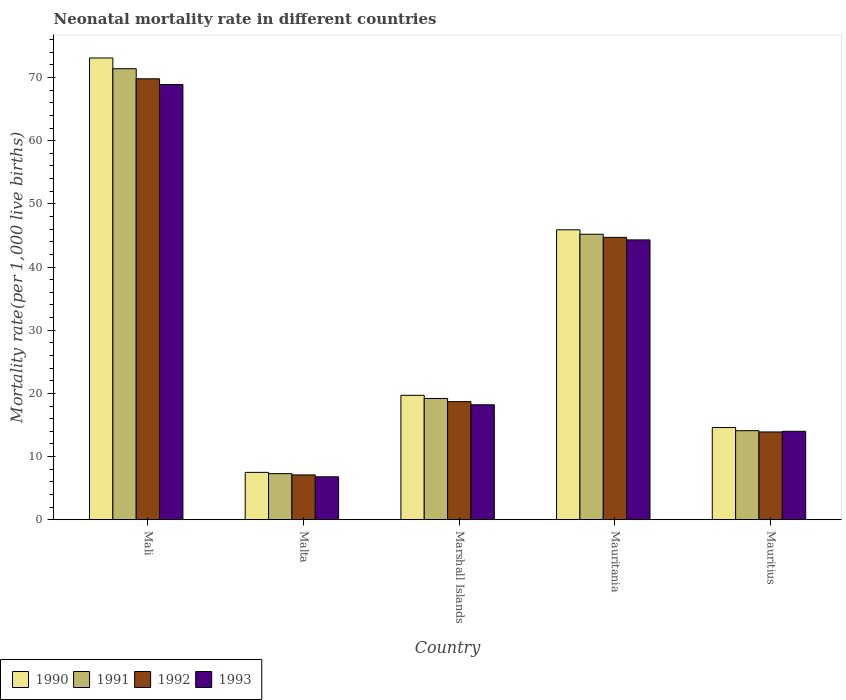How many different coloured bars are there?
Provide a short and direct response. 4. Are the number of bars on each tick of the X-axis equal?
Your answer should be compact. Yes. How many bars are there on the 2nd tick from the left?
Your answer should be very brief. 4. What is the label of the 2nd group of bars from the left?
Give a very brief answer. Malta. What is the neonatal mortality rate in 1992 in Mauritius?
Keep it short and to the point. 13.9. Across all countries, what is the maximum neonatal mortality rate in 1990?
Your answer should be compact. 73.1. Across all countries, what is the minimum neonatal mortality rate in 1991?
Keep it short and to the point. 7.3. In which country was the neonatal mortality rate in 1991 maximum?
Your answer should be very brief. Mali. In which country was the neonatal mortality rate in 1991 minimum?
Provide a short and direct response. Malta. What is the total neonatal mortality rate in 1993 in the graph?
Offer a terse response. 152.2. What is the difference between the neonatal mortality rate in 1991 in Malta and that in Mauritania?
Offer a very short reply. -37.9. What is the difference between the neonatal mortality rate in 1992 in Mauritius and the neonatal mortality rate in 1990 in Marshall Islands?
Your answer should be very brief. -5.8. What is the average neonatal mortality rate in 1992 per country?
Your answer should be very brief. 30.84. What is the difference between the neonatal mortality rate of/in 1992 and neonatal mortality rate of/in 1990 in Mali?
Offer a terse response. -3.3. In how many countries, is the neonatal mortality rate in 1990 greater than 40?
Your response must be concise. 2. What is the ratio of the neonatal mortality rate in 1990 in Marshall Islands to that in Mauritania?
Provide a short and direct response. 0.43. Is the difference between the neonatal mortality rate in 1992 in Mali and Mauritania greater than the difference between the neonatal mortality rate in 1990 in Mali and Mauritania?
Offer a very short reply. No. What is the difference between the highest and the second highest neonatal mortality rate in 1993?
Your answer should be compact. -50.7. What is the difference between the highest and the lowest neonatal mortality rate in 1990?
Make the answer very short. 65.6. In how many countries, is the neonatal mortality rate in 1993 greater than the average neonatal mortality rate in 1993 taken over all countries?
Your answer should be compact. 2. What does the 1st bar from the right in Mali represents?
Make the answer very short. 1993. Is it the case that in every country, the sum of the neonatal mortality rate in 1992 and neonatal mortality rate in 1990 is greater than the neonatal mortality rate in 1991?
Offer a terse response. Yes. How many bars are there?
Provide a succinct answer. 20. Are all the bars in the graph horizontal?
Provide a short and direct response. No. How many countries are there in the graph?
Provide a short and direct response. 5. What is the difference between two consecutive major ticks on the Y-axis?
Your answer should be very brief. 10. Does the graph contain any zero values?
Your answer should be compact. No. Does the graph contain grids?
Offer a terse response. No. Where does the legend appear in the graph?
Offer a very short reply. Bottom left. How many legend labels are there?
Keep it short and to the point. 4. What is the title of the graph?
Offer a terse response. Neonatal mortality rate in different countries. What is the label or title of the X-axis?
Provide a succinct answer. Country. What is the label or title of the Y-axis?
Your answer should be compact. Mortality rate(per 1,0 live births). What is the Mortality rate(per 1,000 live births) of 1990 in Mali?
Provide a succinct answer. 73.1. What is the Mortality rate(per 1,000 live births) of 1991 in Mali?
Give a very brief answer. 71.4. What is the Mortality rate(per 1,000 live births) in 1992 in Mali?
Give a very brief answer. 69.8. What is the Mortality rate(per 1,000 live births) of 1993 in Mali?
Keep it short and to the point. 68.9. What is the Mortality rate(per 1,000 live births) in 1991 in Malta?
Your response must be concise. 7.3. What is the Mortality rate(per 1,000 live births) in 1990 in Marshall Islands?
Keep it short and to the point. 19.7. What is the Mortality rate(per 1,000 live births) of 1991 in Marshall Islands?
Keep it short and to the point. 19.2. What is the Mortality rate(per 1,000 live births) of 1993 in Marshall Islands?
Your answer should be very brief. 18.2. What is the Mortality rate(per 1,000 live births) of 1990 in Mauritania?
Your answer should be very brief. 45.9. What is the Mortality rate(per 1,000 live births) of 1991 in Mauritania?
Provide a succinct answer. 45.2. What is the Mortality rate(per 1,000 live births) in 1992 in Mauritania?
Your answer should be very brief. 44.7. What is the Mortality rate(per 1,000 live births) of 1993 in Mauritania?
Provide a succinct answer. 44.3. What is the Mortality rate(per 1,000 live births) of 1993 in Mauritius?
Offer a terse response. 14. Across all countries, what is the maximum Mortality rate(per 1,000 live births) of 1990?
Ensure brevity in your answer.  73.1. Across all countries, what is the maximum Mortality rate(per 1,000 live births) of 1991?
Your answer should be compact. 71.4. Across all countries, what is the maximum Mortality rate(per 1,000 live births) in 1992?
Offer a terse response. 69.8. Across all countries, what is the maximum Mortality rate(per 1,000 live births) of 1993?
Provide a succinct answer. 68.9. Across all countries, what is the minimum Mortality rate(per 1,000 live births) in 1991?
Your answer should be very brief. 7.3. Across all countries, what is the minimum Mortality rate(per 1,000 live births) of 1992?
Make the answer very short. 7.1. Across all countries, what is the minimum Mortality rate(per 1,000 live births) in 1993?
Offer a terse response. 6.8. What is the total Mortality rate(per 1,000 live births) of 1990 in the graph?
Ensure brevity in your answer.  160.8. What is the total Mortality rate(per 1,000 live births) of 1991 in the graph?
Provide a short and direct response. 157.2. What is the total Mortality rate(per 1,000 live births) in 1992 in the graph?
Provide a succinct answer. 154.2. What is the total Mortality rate(per 1,000 live births) in 1993 in the graph?
Your answer should be compact. 152.2. What is the difference between the Mortality rate(per 1,000 live births) of 1990 in Mali and that in Malta?
Make the answer very short. 65.6. What is the difference between the Mortality rate(per 1,000 live births) of 1991 in Mali and that in Malta?
Keep it short and to the point. 64.1. What is the difference between the Mortality rate(per 1,000 live births) in 1992 in Mali and that in Malta?
Ensure brevity in your answer.  62.7. What is the difference between the Mortality rate(per 1,000 live births) in 1993 in Mali and that in Malta?
Your answer should be compact. 62.1. What is the difference between the Mortality rate(per 1,000 live births) of 1990 in Mali and that in Marshall Islands?
Provide a short and direct response. 53.4. What is the difference between the Mortality rate(per 1,000 live births) in 1991 in Mali and that in Marshall Islands?
Give a very brief answer. 52.2. What is the difference between the Mortality rate(per 1,000 live births) of 1992 in Mali and that in Marshall Islands?
Keep it short and to the point. 51.1. What is the difference between the Mortality rate(per 1,000 live births) of 1993 in Mali and that in Marshall Islands?
Keep it short and to the point. 50.7. What is the difference between the Mortality rate(per 1,000 live births) of 1990 in Mali and that in Mauritania?
Offer a terse response. 27.2. What is the difference between the Mortality rate(per 1,000 live births) of 1991 in Mali and that in Mauritania?
Make the answer very short. 26.2. What is the difference between the Mortality rate(per 1,000 live births) of 1992 in Mali and that in Mauritania?
Provide a succinct answer. 25.1. What is the difference between the Mortality rate(per 1,000 live births) of 1993 in Mali and that in Mauritania?
Provide a short and direct response. 24.6. What is the difference between the Mortality rate(per 1,000 live births) of 1990 in Mali and that in Mauritius?
Keep it short and to the point. 58.5. What is the difference between the Mortality rate(per 1,000 live births) in 1991 in Mali and that in Mauritius?
Ensure brevity in your answer.  57.3. What is the difference between the Mortality rate(per 1,000 live births) in 1992 in Mali and that in Mauritius?
Provide a short and direct response. 55.9. What is the difference between the Mortality rate(per 1,000 live births) of 1993 in Mali and that in Mauritius?
Provide a short and direct response. 54.9. What is the difference between the Mortality rate(per 1,000 live births) of 1990 in Malta and that in Marshall Islands?
Offer a very short reply. -12.2. What is the difference between the Mortality rate(per 1,000 live births) of 1991 in Malta and that in Marshall Islands?
Your answer should be compact. -11.9. What is the difference between the Mortality rate(per 1,000 live births) of 1992 in Malta and that in Marshall Islands?
Offer a terse response. -11.6. What is the difference between the Mortality rate(per 1,000 live births) of 1993 in Malta and that in Marshall Islands?
Provide a succinct answer. -11.4. What is the difference between the Mortality rate(per 1,000 live births) of 1990 in Malta and that in Mauritania?
Offer a terse response. -38.4. What is the difference between the Mortality rate(per 1,000 live births) of 1991 in Malta and that in Mauritania?
Make the answer very short. -37.9. What is the difference between the Mortality rate(per 1,000 live births) of 1992 in Malta and that in Mauritania?
Provide a succinct answer. -37.6. What is the difference between the Mortality rate(per 1,000 live births) of 1993 in Malta and that in Mauritania?
Provide a succinct answer. -37.5. What is the difference between the Mortality rate(per 1,000 live births) in 1990 in Malta and that in Mauritius?
Provide a short and direct response. -7.1. What is the difference between the Mortality rate(per 1,000 live births) of 1992 in Malta and that in Mauritius?
Your answer should be very brief. -6.8. What is the difference between the Mortality rate(per 1,000 live births) in 1990 in Marshall Islands and that in Mauritania?
Keep it short and to the point. -26.2. What is the difference between the Mortality rate(per 1,000 live births) in 1993 in Marshall Islands and that in Mauritania?
Offer a very short reply. -26.1. What is the difference between the Mortality rate(per 1,000 live births) of 1990 in Marshall Islands and that in Mauritius?
Keep it short and to the point. 5.1. What is the difference between the Mortality rate(per 1,000 live births) in 1993 in Marshall Islands and that in Mauritius?
Offer a terse response. 4.2. What is the difference between the Mortality rate(per 1,000 live births) of 1990 in Mauritania and that in Mauritius?
Give a very brief answer. 31.3. What is the difference between the Mortality rate(per 1,000 live births) of 1991 in Mauritania and that in Mauritius?
Keep it short and to the point. 31.1. What is the difference between the Mortality rate(per 1,000 live births) of 1992 in Mauritania and that in Mauritius?
Provide a succinct answer. 30.8. What is the difference between the Mortality rate(per 1,000 live births) in 1993 in Mauritania and that in Mauritius?
Offer a terse response. 30.3. What is the difference between the Mortality rate(per 1,000 live births) in 1990 in Mali and the Mortality rate(per 1,000 live births) in 1991 in Malta?
Your answer should be compact. 65.8. What is the difference between the Mortality rate(per 1,000 live births) of 1990 in Mali and the Mortality rate(per 1,000 live births) of 1992 in Malta?
Your answer should be compact. 66. What is the difference between the Mortality rate(per 1,000 live births) in 1990 in Mali and the Mortality rate(per 1,000 live births) in 1993 in Malta?
Your answer should be compact. 66.3. What is the difference between the Mortality rate(per 1,000 live births) in 1991 in Mali and the Mortality rate(per 1,000 live births) in 1992 in Malta?
Give a very brief answer. 64.3. What is the difference between the Mortality rate(per 1,000 live births) in 1991 in Mali and the Mortality rate(per 1,000 live births) in 1993 in Malta?
Ensure brevity in your answer.  64.6. What is the difference between the Mortality rate(per 1,000 live births) in 1990 in Mali and the Mortality rate(per 1,000 live births) in 1991 in Marshall Islands?
Provide a short and direct response. 53.9. What is the difference between the Mortality rate(per 1,000 live births) in 1990 in Mali and the Mortality rate(per 1,000 live births) in 1992 in Marshall Islands?
Ensure brevity in your answer.  54.4. What is the difference between the Mortality rate(per 1,000 live births) of 1990 in Mali and the Mortality rate(per 1,000 live births) of 1993 in Marshall Islands?
Provide a succinct answer. 54.9. What is the difference between the Mortality rate(per 1,000 live births) in 1991 in Mali and the Mortality rate(per 1,000 live births) in 1992 in Marshall Islands?
Ensure brevity in your answer.  52.7. What is the difference between the Mortality rate(per 1,000 live births) of 1991 in Mali and the Mortality rate(per 1,000 live births) of 1993 in Marshall Islands?
Make the answer very short. 53.2. What is the difference between the Mortality rate(per 1,000 live births) in 1992 in Mali and the Mortality rate(per 1,000 live births) in 1993 in Marshall Islands?
Offer a terse response. 51.6. What is the difference between the Mortality rate(per 1,000 live births) of 1990 in Mali and the Mortality rate(per 1,000 live births) of 1991 in Mauritania?
Give a very brief answer. 27.9. What is the difference between the Mortality rate(per 1,000 live births) of 1990 in Mali and the Mortality rate(per 1,000 live births) of 1992 in Mauritania?
Offer a terse response. 28.4. What is the difference between the Mortality rate(per 1,000 live births) of 1990 in Mali and the Mortality rate(per 1,000 live births) of 1993 in Mauritania?
Offer a very short reply. 28.8. What is the difference between the Mortality rate(per 1,000 live births) of 1991 in Mali and the Mortality rate(per 1,000 live births) of 1992 in Mauritania?
Your response must be concise. 26.7. What is the difference between the Mortality rate(per 1,000 live births) of 1991 in Mali and the Mortality rate(per 1,000 live births) of 1993 in Mauritania?
Offer a terse response. 27.1. What is the difference between the Mortality rate(per 1,000 live births) of 1992 in Mali and the Mortality rate(per 1,000 live births) of 1993 in Mauritania?
Provide a succinct answer. 25.5. What is the difference between the Mortality rate(per 1,000 live births) in 1990 in Mali and the Mortality rate(per 1,000 live births) in 1991 in Mauritius?
Offer a very short reply. 59. What is the difference between the Mortality rate(per 1,000 live births) of 1990 in Mali and the Mortality rate(per 1,000 live births) of 1992 in Mauritius?
Ensure brevity in your answer.  59.2. What is the difference between the Mortality rate(per 1,000 live births) of 1990 in Mali and the Mortality rate(per 1,000 live births) of 1993 in Mauritius?
Your answer should be compact. 59.1. What is the difference between the Mortality rate(per 1,000 live births) in 1991 in Mali and the Mortality rate(per 1,000 live births) in 1992 in Mauritius?
Ensure brevity in your answer.  57.5. What is the difference between the Mortality rate(per 1,000 live births) in 1991 in Mali and the Mortality rate(per 1,000 live births) in 1993 in Mauritius?
Make the answer very short. 57.4. What is the difference between the Mortality rate(per 1,000 live births) of 1992 in Mali and the Mortality rate(per 1,000 live births) of 1993 in Mauritius?
Keep it short and to the point. 55.8. What is the difference between the Mortality rate(per 1,000 live births) in 1990 in Malta and the Mortality rate(per 1,000 live births) in 1992 in Marshall Islands?
Give a very brief answer. -11.2. What is the difference between the Mortality rate(per 1,000 live births) of 1991 in Malta and the Mortality rate(per 1,000 live births) of 1992 in Marshall Islands?
Ensure brevity in your answer.  -11.4. What is the difference between the Mortality rate(per 1,000 live births) in 1991 in Malta and the Mortality rate(per 1,000 live births) in 1993 in Marshall Islands?
Give a very brief answer. -10.9. What is the difference between the Mortality rate(per 1,000 live births) in 1992 in Malta and the Mortality rate(per 1,000 live births) in 1993 in Marshall Islands?
Provide a succinct answer. -11.1. What is the difference between the Mortality rate(per 1,000 live births) in 1990 in Malta and the Mortality rate(per 1,000 live births) in 1991 in Mauritania?
Ensure brevity in your answer.  -37.7. What is the difference between the Mortality rate(per 1,000 live births) in 1990 in Malta and the Mortality rate(per 1,000 live births) in 1992 in Mauritania?
Provide a short and direct response. -37.2. What is the difference between the Mortality rate(per 1,000 live births) in 1990 in Malta and the Mortality rate(per 1,000 live births) in 1993 in Mauritania?
Ensure brevity in your answer.  -36.8. What is the difference between the Mortality rate(per 1,000 live births) in 1991 in Malta and the Mortality rate(per 1,000 live births) in 1992 in Mauritania?
Ensure brevity in your answer.  -37.4. What is the difference between the Mortality rate(per 1,000 live births) in 1991 in Malta and the Mortality rate(per 1,000 live births) in 1993 in Mauritania?
Offer a very short reply. -37. What is the difference between the Mortality rate(per 1,000 live births) of 1992 in Malta and the Mortality rate(per 1,000 live births) of 1993 in Mauritania?
Your answer should be compact. -37.2. What is the difference between the Mortality rate(per 1,000 live births) in 1990 in Malta and the Mortality rate(per 1,000 live births) in 1993 in Mauritius?
Your answer should be compact. -6.5. What is the difference between the Mortality rate(per 1,000 live births) of 1991 in Malta and the Mortality rate(per 1,000 live births) of 1992 in Mauritius?
Your response must be concise. -6.6. What is the difference between the Mortality rate(per 1,000 live births) in 1991 in Malta and the Mortality rate(per 1,000 live births) in 1993 in Mauritius?
Provide a succinct answer. -6.7. What is the difference between the Mortality rate(per 1,000 live births) in 1990 in Marshall Islands and the Mortality rate(per 1,000 live births) in 1991 in Mauritania?
Provide a short and direct response. -25.5. What is the difference between the Mortality rate(per 1,000 live births) in 1990 in Marshall Islands and the Mortality rate(per 1,000 live births) in 1992 in Mauritania?
Keep it short and to the point. -25. What is the difference between the Mortality rate(per 1,000 live births) in 1990 in Marshall Islands and the Mortality rate(per 1,000 live births) in 1993 in Mauritania?
Provide a succinct answer. -24.6. What is the difference between the Mortality rate(per 1,000 live births) in 1991 in Marshall Islands and the Mortality rate(per 1,000 live births) in 1992 in Mauritania?
Your answer should be compact. -25.5. What is the difference between the Mortality rate(per 1,000 live births) in 1991 in Marshall Islands and the Mortality rate(per 1,000 live births) in 1993 in Mauritania?
Make the answer very short. -25.1. What is the difference between the Mortality rate(per 1,000 live births) of 1992 in Marshall Islands and the Mortality rate(per 1,000 live births) of 1993 in Mauritania?
Give a very brief answer. -25.6. What is the difference between the Mortality rate(per 1,000 live births) of 1990 in Marshall Islands and the Mortality rate(per 1,000 live births) of 1991 in Mauritius?
Provide a succinct answer. 5.6. What is the difference between the Mortality rate(per 1,000 live births) of 1990 in Marshall Islands and the Mortality rate(per 1,000 live births) of 1992 in Mauritius?
Offer a terse response. 5.8. What is the difference between the Mortality rate(per 1,000 live births) in 1990 in Mauritania and the Mortality rate(per 1,000 live births) in 1991 in Mauritius?
Make the answer very short. 31.8. What is the difference between the Mortality rate(per 1,000 live births) in 1990 in Mauritania and the Mortality rate(per 1,000 live births) in 1992 in Mauritius?
Offer a terse response. 32. What is the difference between the Mortality rate(per 1,000 live births) of 1990 in Mauritania and the Mortality rate(per 1,000 live births) of 1993 in Mauritius?
Make the answer very short. 31.9. What is the difference between the Mortality rate(per 1,000 live births) of 1991 in Mauritania and the Mortality rate(per 1,000 live births) of 1992 in Mauritius?
Your response must be concise. 31.3. What is the difference between the Mortality rate(per 1,000 live births) in 1991 in Mauritania and the Mortality rate(per 1,000 live births) in 1993 in Mauritius?
Your answer should be compact. 31.2. What is the difference between the Mortality rate(per 1,000 live births) in 1992 in Mauritania and the Mortality rate(per 1,000 live births) in 1993 in Mauritius?
Keep it short and to the point. 30.7. What is the average Mortality rate(per 1,000 live births) of 1990 per country?
Provide a succinct answer. 32.16. What is the average Mortality rate(per 1,000 live births) of 1991 per country?
Your answer should be very brief. 31.44. What is the average Mortality rate(per 1,000 live births) in 1992 per country?
Your response must be concise. 30.84. What is the average Mortality rate(per 1,000 live births) of 1993 per country?
Your answer should be compact. 30.44. What is the difference between the Mortality rate(per 1,000 live births) in 1990 and Mortality rate(per 1,000 live births) in 1991 in Mali?
Your answer should be very brief. 1.7. What is the difference between the Mortality rate(per 1,000 live births) in 1991 and Mortality rate(per 1,000 live births) in 1992 in Mali?
Keep it short and to the point. 1.6. What is the difference between the Mortality rate(per 1,000 live births) of 1991 and Mortality rate(per 1,000 live births) of 1993 in Mali?
Offer a terse response. 2.5. What is the difference between the Mortality rate(per 1,000 live births) in 1992 and Mortality rate(per 1,000 live births) in 1993 in Mali?
Give a very brief answer. 0.9. What is the difference between the Mortality rate(per 1,000 live births) of 1991 and Mortality rate(per 1,000 live births) of 1992 in Malta?
Your answer should be compact. 0.2. What is the difference between the Mortality rate(per 1,000 live births) of 1991 and Mortality rate(per 1,000 live births) of 1993 in Malta?
Keep it short and to the point. 0.5. What is the difference between the Mortality rate(per 1,000 live births) in 1990 and Mortality rate(per 1,000 live births) in 1993 in Marshall Islands?
Give a very brief answer. 1.5. What is the difference between the Mortality rate(per 1,000 live births) of 1991 and Mortality rate(per 1,000 live births) of 1993 in Marshall Islands?
Ensure brevity in your answer.  1. What is the difference between the Mortality rate(per 1,000 live births) of 1992 and Mortality rate(per 1,000 live births) of 1993 in Marshall Islands?
Your answer should be very brief. 0.5. What is the difference between the Mortality rate(per 1,000 live births) of 1990 and Mortality rate(per 1,000 live births) of 1993 in Mauritania?
Provide a succinct answer. 1.6. What is the difference between the Mortality rate(per 1,000 live births) of 1992 and Mortality rate(per 1,000 live births) of 1993 in Mauritania?
Your answer should be very brief. 0.4. What is the difference between the Mortality rate(per 1,000 live births) in 1990 and Mortality rate(per 1,000 live births) in 1991 in Mauritius?
Give a very brief answer. 0.5. What is the difference between the Mortality rate(per 1,000 live births) in 1990 and Mortality rate(per 1,000 live births) in 1992 in Mauritius?
Give a very brief answer. 0.7. What is the difference between the Mortality rate(per 1,000 live births) of 1991 and Mortality rate(per 1,000 live births) of 1992 in Mauritius?
Offer a terse response. 0.2. What is the difference between the Mortality rate(per 1,000 live births) in 1991 and Mortality rate(per 1,000 live births) in 1993 in Mauritius?
Your answer should be very brief. 0.1. What is the ratio of the Mortality rate(per 1,000 live births) of 1990 in Mali to that in Malta?
Your answer should be compact. 9.75. What is the ratio of the Mortality rate(per 1,000 live births) of 1991 in Mali to that in Malta?
Offer a very short reply. 9.78. What is the ratio of the Mortality rate(per 1,000 live births) in 1992 in Mali to that in Malta?
Make the answer very short. 9.83. What is the ratio of the Mortality rate(per 1,000 live births) of 1993 in Mali to that in Malta?
Provide a short and direct response. 10.13. What is the ratio of the Mortality rate(per 1,000 live births) of 1990 in Mali to that in Marshall Islands?
Give a very brief answer. 3.71. What is the ratio of the Mortality rate(per 1,000 live births) of 1991 in Mali to that in Marshall Islands?
Your response must be concise. 3.72. What is the ratio of the Mortality rate(per 1,000 live births) of 1992 in Mali to that in Marshall Islands?
Your answer should be compact. 3.73. What is the ratio of the Mortality rate(per 1,000 live births) of 1993 in Mali to that in Marshall Islands?
Keep it short and to the point. 3.79. What is the ratio of the Mortality rate(per 1,000 live births) in 1990 in Mali to that in Mauritania?
Provide a short and direct response. 1.59. What is the ratio of the Mortality rate(per 1,000 live births) in 1991 in Mali to that in Mauritania?
Offer a very short reply. 1.58. What is the ratio of the Mortality rate(per 1,000 live births) of 1992 in Mali to that in Mauritania?
Give a very brief answer. 1.56. What is the ratio of the Mortality rate(per 1,000 live births) of 1993 in Mali to that in Mauritania?
Provide a short and direct response. 1.56. What is the ratio of the Mortality rate(per 1,000 live births) of 1990 in Mali to that in Mauritius?
Offer a terse response. 5.01. What is the ratio of the Mortality rate(per 1,000 live births) of 1991 in Mali to that in Mauritius?
Provide a succinct answer. 5.06. What is the ratio of the Mortality rate(per 1,000 live births) of 1992 in Mali to that in Mauritius?
Your answer should be very brief. 5.02. What is the ratio of the Mortality rate(per 1,000 live births) in 1993 in Mali to that in Mauritius?
Your answer should be very brief. 4.92. What is the ratio of the Mortality rate(per 1,000 live births) of 1990 in Malta to that in Marshall Islands?
Provide a succinct answer. 0.38. What is the ratio of the Mortality rate(per 1,000 live births) of 1991 in Malta to that in Marshall Islands?
Offer a very short reply. 0.38. What is the ratio of the Mortality rate(per 1,000 live births) of 1992 in Malta to that in Marshall Islands?
Keep it short and to the point. 0.38. What is the ratio of the Mortality rate(per 1,000 live births) of 1993 in Malta to that in Marshall Islands?
Keep it short and to the point. 0.37. What is the ratio of the Mortality rate(per 1,000 live births) of 1990 in Malta to that in Mauritania?
Provide a short and direct response. 0.16. What is the ratio of the Mortality rate(per 1,000 live births) of 1991 in Malta to that in Mauritania?
Your answer should be compact. 0.16. What is the ratio of the Mortality rate(per 1,000 live births) of 1992 in Malta to that in Mauritania?
Your answer should be very brief. 0.16. What is the ratio of the Mortality rate(per 1,000 live births) of 1993 in Malta to that in Mauritania?
Ensure brevity in your answer.  0.15. What is the ratio of the Mortality rate(per 1,000 live births) of 1990 in Malta to that in Mauritius?
Offer a terse response. 0.51. What is the ratio of the Mortality rate(per 1,000 live births) in 1991 in Malta to that in Mauritius?
Keep it short and to the point. 0.52. What is the ratio of the Mortality rate(per 1,000 live births) in 1992 in Malta to that in Mauritius?
Provide a succinct answer. 0.51. What is the ratio of the Mortality rate(per 1,000 live births) in 1993 in Malta to that in Mauritius?
Keep it short and to the point. 0.49. What is the ratio of the Mortality rate(per 1,000 live births) of 1990 in Marshall Islands to that in Mauritania?
Your answer should be compact. 0.43. What is the ratio of the Mortality rate(per 1,000 live births) in 1991 in Marshall Islands to that in Mauritania?
Provide a succinct answer. 0.42. What is the ratio of the Mortality rate(per 1,000 live births) in 1992 in Marshall Islands to that in Mauritania?
Provide a succinct answer. 0.42. What is the ratio of the Mortality rate(per 1,000 live births) in 1993 in Marshall Islands to that in Mauritania?
Offer a very short reply. 0.41. What is the ratio of the Mortality rate(per 1,000 live births) of 1990 in Marshall Islands to that in Mauritius?
Provide a succinct answer. 1.35. What is the ratio of the Mortality rate(per 1,000 live births) of 1991 in Marshall Islands to that in Mauritius?
Your answer should be compact. 1.36. What is the ratio of the Mortality rate(per 1,000 live births) of 1992 in Marshall Islands to that in Mauritius?
Offer a very short reply. 1.35. What is the ratio of the Mortality rate(per 1,000 live births) of 1990 in Mauritania to that in Mauritius?
Ensure brevity in your answer.  3.14. What is the ratio of the Mortality rate(per 1,000 live births) in 1991 in Mauritania to that in Mauritius?
Make the answer very short. 3.21. What is the ratio of the Mortality rate(per 1,000 live births) in 1992 in Mauritania to that in Mauritius?
Make the answer very short. 3.22. What is the ratio of the Mortality rate(per 1,000 live births) of 1993 in Mauritania to that in Mauritius?
Ensure brevity in your answer.  3.16. What is the difference between the highest and the second highest Mortality rate(per 1,000 live births) of 1990?
Make the answer very short. 27.2. What is the difference between the highest and the second highest Mortality rate(per 1,000 live births) in 1991?
Offer a terse response. 26.2. What is the difference between the highest and the second highest Mortality rate(per 1,000 live births) in 1992?
Offer a very short reply. 25.1. What is the difference between the highest and the second highest Mortality rate(per 1,000 live births) of 1993?
Provide a short and direct response. 24.6. What is the difference between the highest and the lowest Mortality rate(per 1,000 live births) of 1990?
Offer a very short reply. 65.6. What is the difference between the highest and the lowest Mortality rate(per 1,000 live births) in 1991?
Keep it short and to the point. 64.1. What is the difference between the highest and the lowest Mortality rate(per 1,000 live births) of 1992?
Ensure brevity in your answer.  62.7. What is the difference between the highest and the lowest Mortality rate(per 1,000 live births) in 1993?
Offer a very short reply. 62.1. 